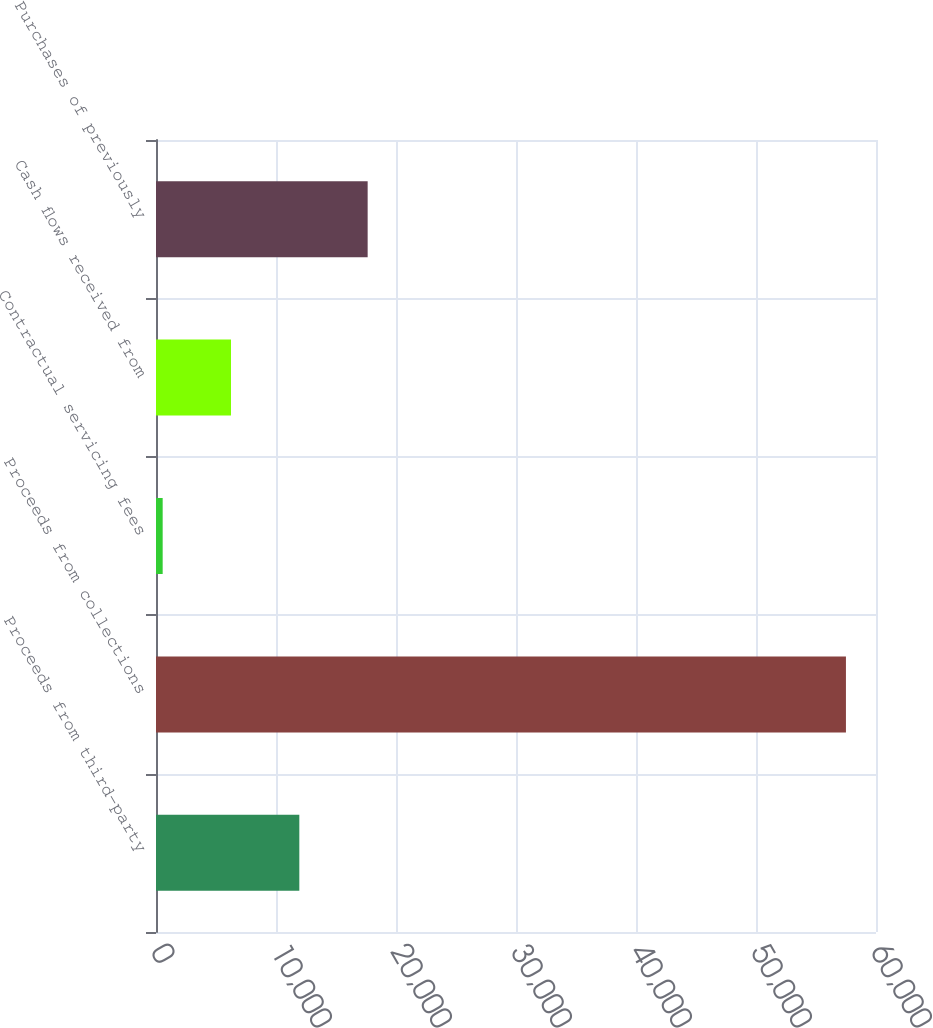Convert chart to OTSL. <chart><loc_0><loc_0><loc_500><loc_500><bar_chart><fcel>Proceeds from third-party<fcel>Proceeds from collections<fcel>Contractual servicing fees<fcel>Cash flows received from<fcel>Purchases of previously<nl><fcel>11943.8<fcel>57495<fcel>556<fcel>6249.9<fcel>17637.7<nl></chart> 